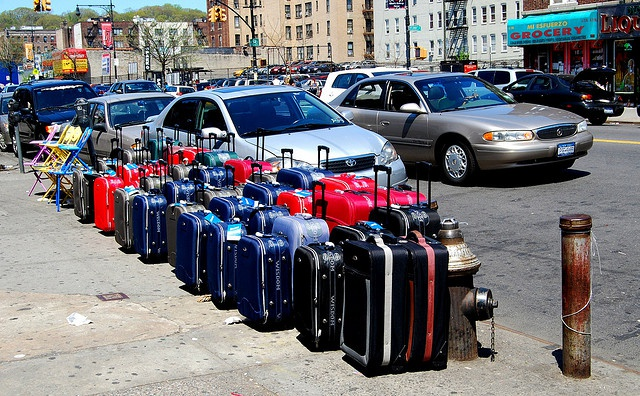Describe the objects in this image and their specific colors. I can see car in lightblue, black, gray, and darkgray tones, car in lightblue, black, white, and navy tones, suitcase in lightblue, black, gray, darkgray, and lightgray tones, suitcase in lightblue, black, navy, blue, and white tones, and suitcase in lightblue, black, gray, darkgray, and lightgray tones in this image. 